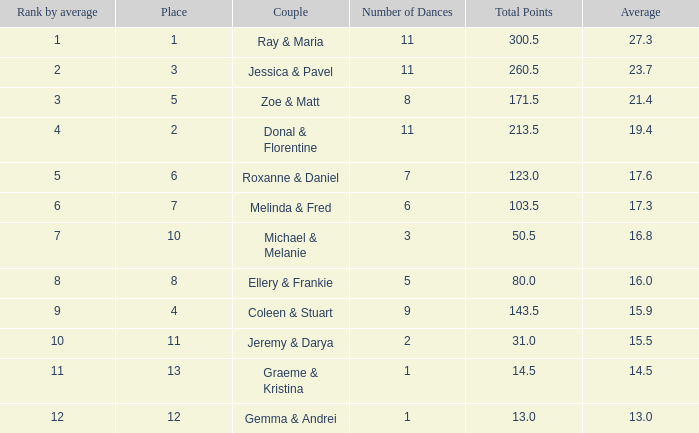What place would you be in if your rank by average is less than 2.0? 1.0. 